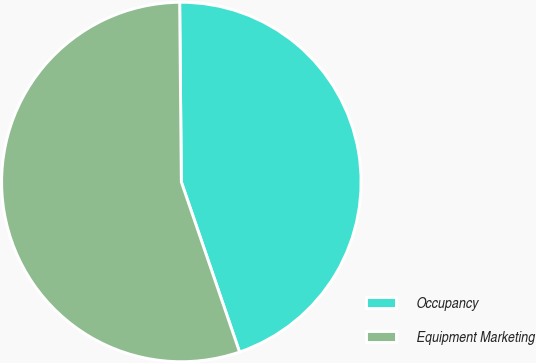<chart> <loc_0><loc_0><loc_500><loc_500><pie_chart><fcel>Occupancy<fcel>Equipment Marketing<nl><fcel>44.9%<fcel>55.1%<nl></chart> 